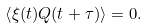Convert formula to latex. <formula><loc_0><loc_0><loc_500><loc_500>\left < \xi ( t ) Q ( t + \tau ) \right > = 0 .</formula> 